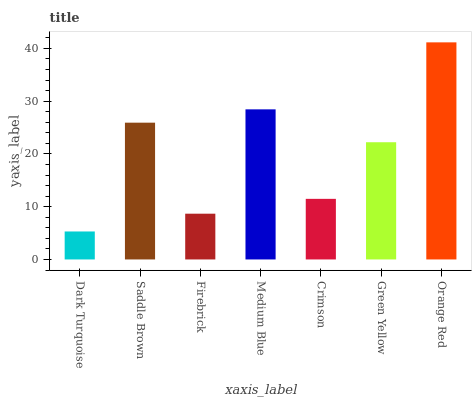Is Dark Turquoise the minimum?
Answer yes or no. Yes. Is Orange Red the maximum?
Answer yes or no. Yes. Is Saddle Brown the minimum?
Answer yes or no. No. Is Saddle Brown the maximum?
Answer yes or no. No. Is Saddle Brown greater than Dark Turquoise?
Answer yes or no. Yes. Is Dark Turquoise less than Saddle Brown?
Answer yes or no. Yes. Is Dark Turquoise greater than Saddle Brown?
Answer yes or no. No. Is Saddle Brown less than Dark Turquoise?
Answer yes or no. No. Is Green Yellow the high median?
Answer yes or no. Yes. Is Green Yellow the low median?
Answer yes or no. Yes. Is Dark Turquoise the high median?
Answer yes or no. No. Is Saddle Brown the low median?
Answer yes or no. No. 